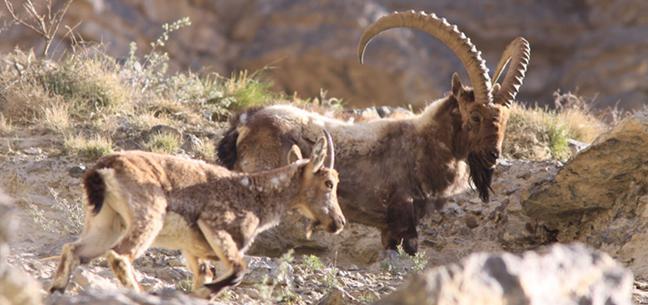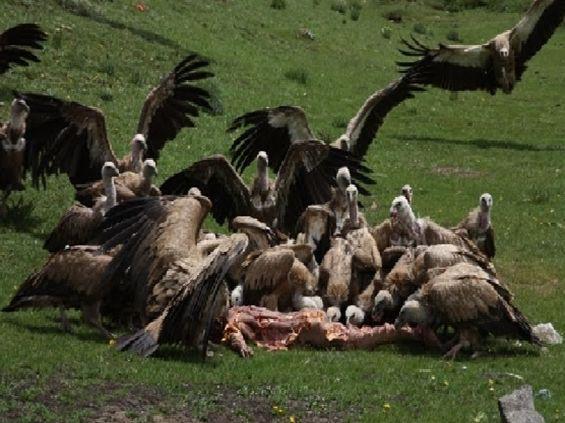The first image is the image on the left, the second image is the image on the right. Given the left and right images, does the statement "The left and right image contains the same number of vaulters" hold true? Answer yes or no. No. The first image is the image on the left, the second image is the image on the right. Analyze the images presented: Is the assertion "In all images at least one bird has its wings open, and in one image that bird is on the ground and in the other it is in the air." valid? Answer yes or no. No. 